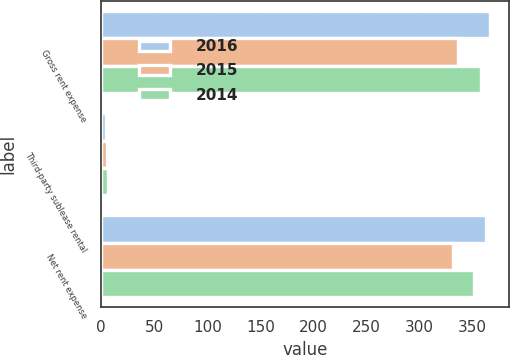Convert chart. <chart><loc_0><loc_0><loc_500><loc_500><stacked_bar_chart><ecel><fcel>Gross rent expense<fcel>Third-party sublease rental<fcel>Net rent expense<nl><fcel>2016<fcel>366.1<fcel>4.1<fcel>362<nl><fcel>2015<fcel>336.5<fcel>5.5<fcel>331<nl><fcel>2014<fcel>357.7<fcel>6.1<fcel>351.6<nl></chart> 